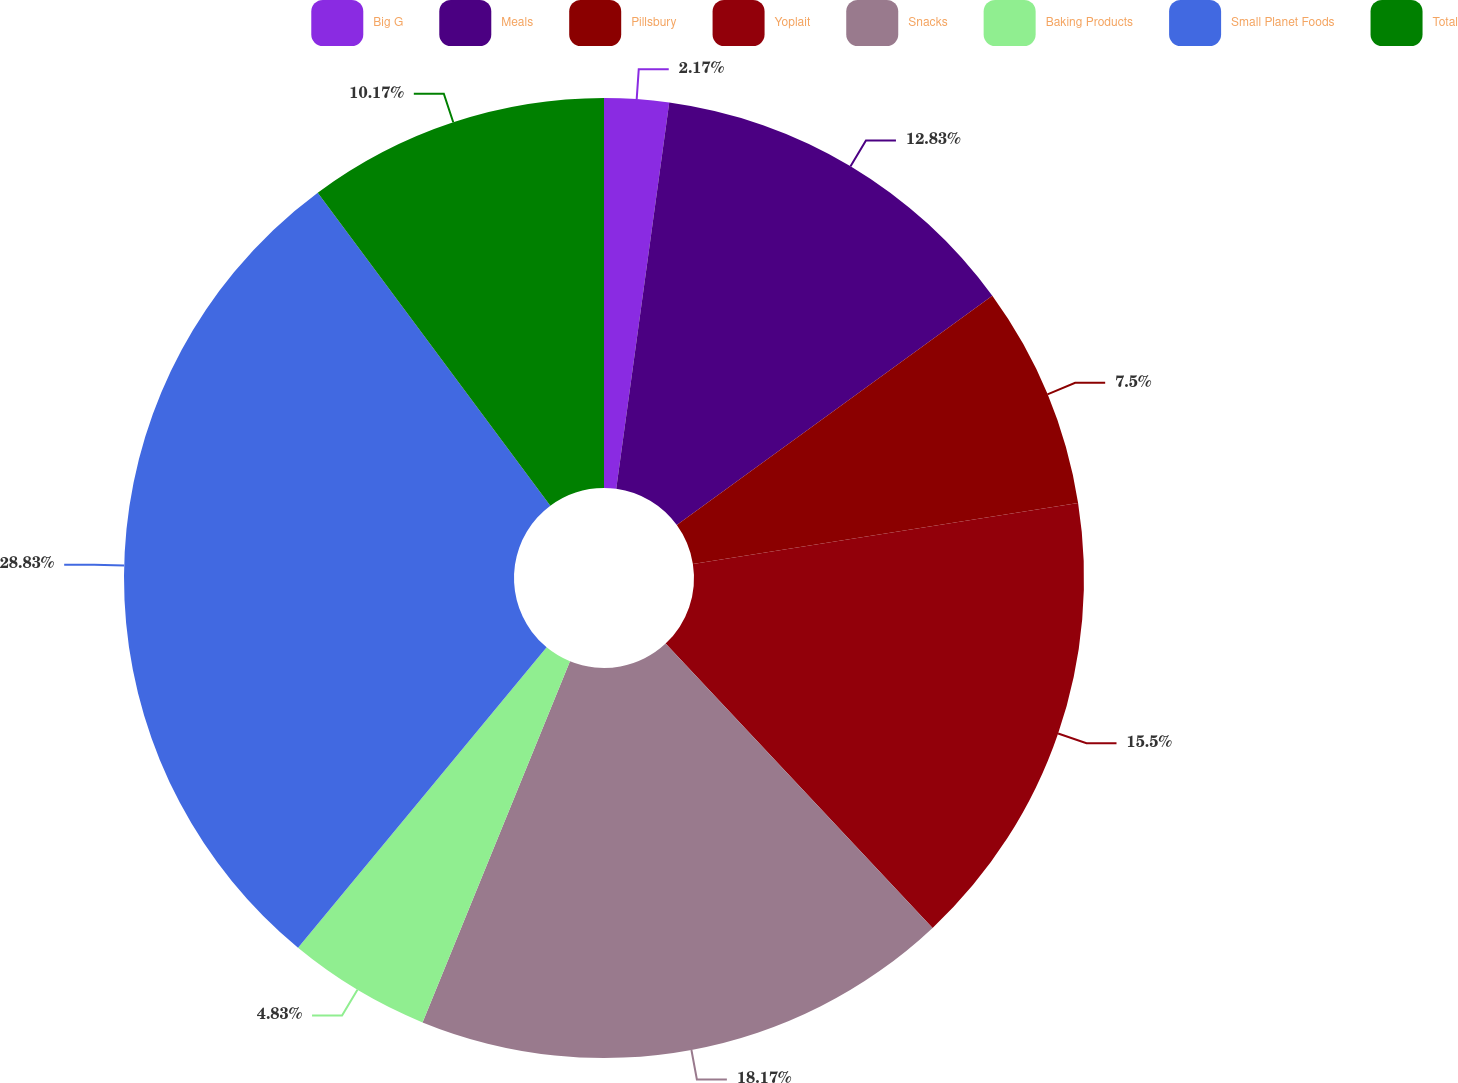<chart> <loc_0><loc_0><loc_500><loc_500><pie_chart><fcel>Big G<fcel>Meals<fcel>Pillsbury<fcel>Yoplait<fcel>Snacks<fcel>Baking Products<fcel>Small Planet Foods<fcel>Total<nl><fcel>2.17%<fcel>12.83%<fcel>7.5%<fcel>15.5%<fcel>18.17%<fcel>4.83%<fcel>28.83%<fcel>10.17%<nl></chart> 